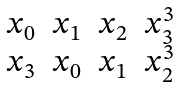<formula> <loc_0><loc_0><loc_500><loc_500>\begin{matrix} x _ { 0 } & x _ { 1 } & x _ { 2 } & x _ { 3 } ^ { 3 } \\ x _ { 3 } & x _ { 0 } & x _ { 1 } & x _ { 2 } ^ { 3 } \end{matrix}</formula> 